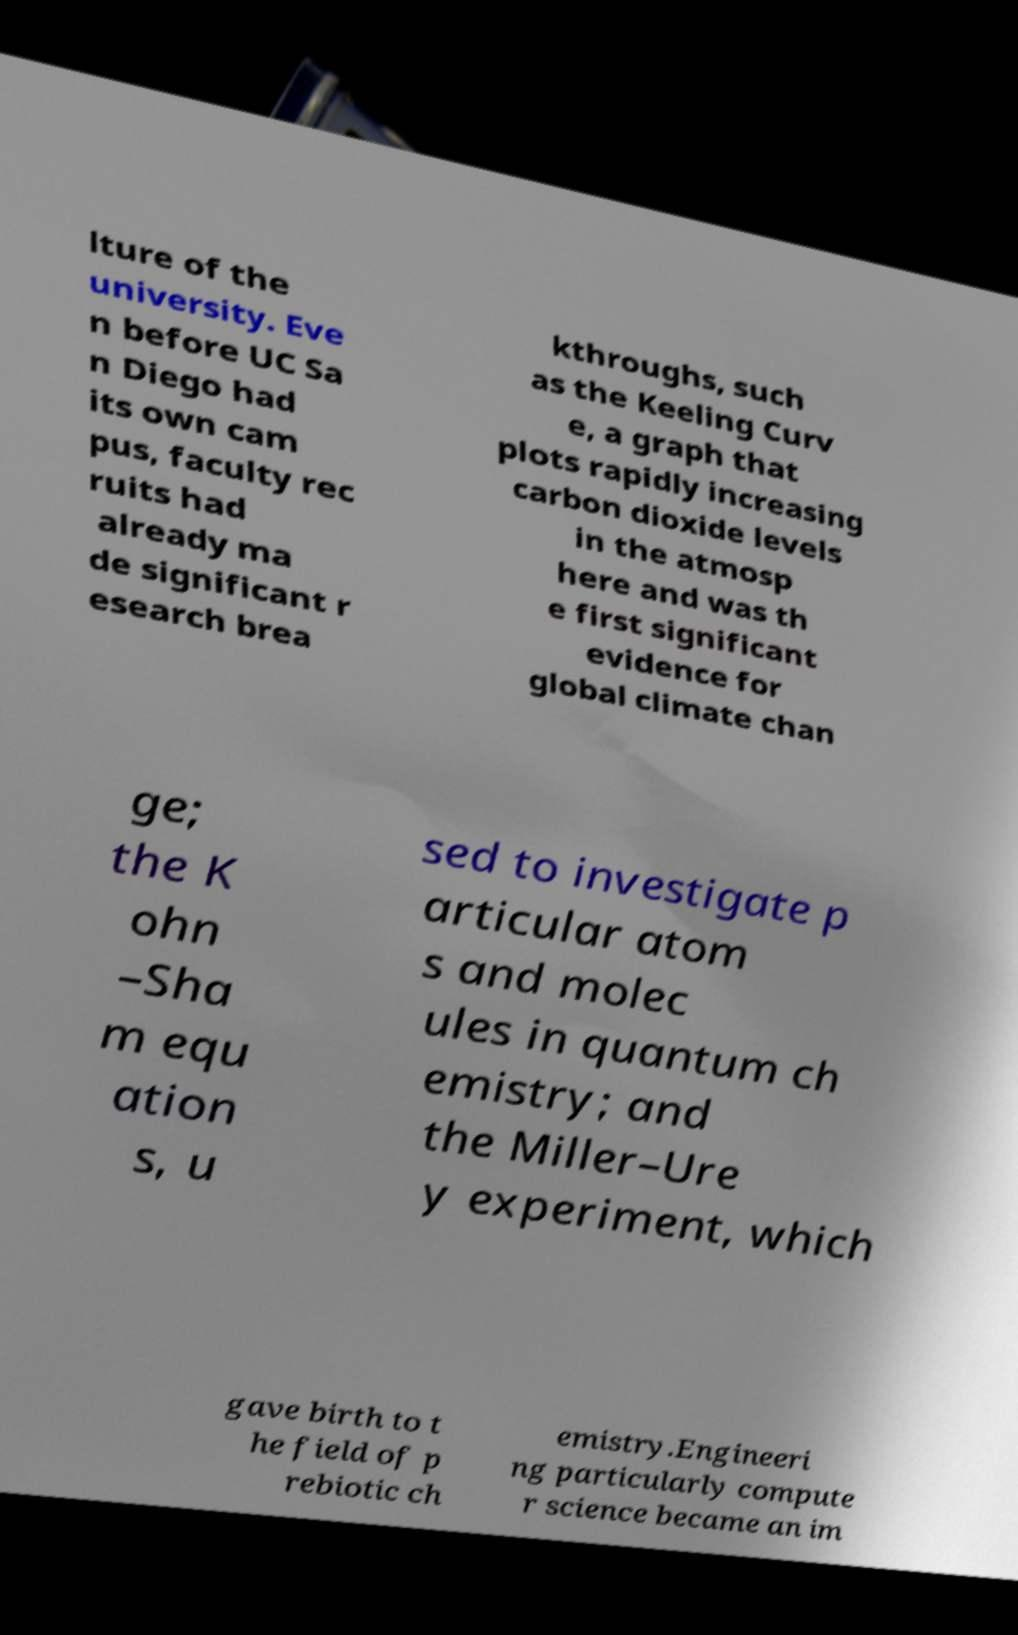Could you extract and type out the text from this image? lture of the university. Eve n before UC Sa n Diego had its own cam pus, faculty rec ruits had already ma de significant r esearch brea kthroughs, such as the Keeling Curv e, a graph that plots rapidly increasing carbon dioxide levels in the atmosp here and was th e first significant evidence for global climate chan ge; the K ohn –Sha m equ ation s, u sed to investigate p articular atom s and molec ules in quantum ch emistry; and the Miller–Ure y experiment, which gave birth to t he field of p rebiotic ch emistry.Engineeri ng particularly compute r science became an im 